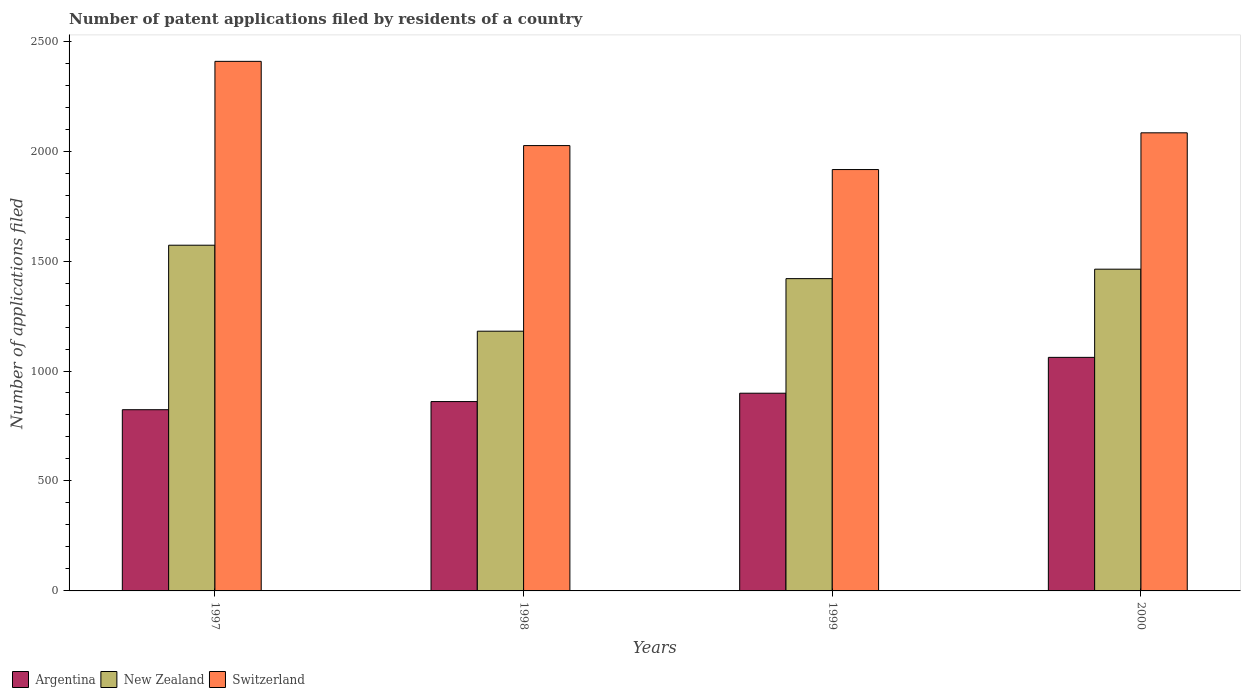How many groups of bars are there?
Your answer should be very brief. 4. How many bars are there on the 4th tick from the left?
Your answer should be very brief. 3. How many bars are there on the 2nd tick from the right?
Your answer should be compact. 3. What is the label of the 2nd group of bars from the left?
Make the answer very short. 1998. What is the number of applications filed in New Zealand in 1997?
Ensure brevity in your answer.  1572. Across all years, what is the maximum number of applications filed in Switzerland?
Provide a short and direct response. 2408. Across all years, what is the minimum number of applications filed in New Zealand?
Offer a very short reply. 1181. In which year was the number of applications filed in Argentina maximum?
Offer a terse response. 2000. In which year was the number of applications filed in Switzerland minimum?
Your answer should be compact. 1999. What is the total number of applications filed in Switzerland in the graph?
Offer a very short reply. 8432. What is the difference between the number of applications filed in Switzerland in 1997 and that in 1998?
Your answer should be very brief. 383. What is the difference between the number of applications filed in Switzerland in 1998 and the number of applications filed in New Zealand in 1999?
Ensure brevity in your answer.  605. What is the average number of applications filed in New Zealand per year?
Your answer should be compact. 1409. In the year 1998, what is the difference between the number of applications filed in Switzerland and number of applications filed in Argentina?
Your answer should be very brief. 1164. In how many years, is the number of applications filed in New Zealand greater than 1300?
Your response must be concise. 3. What is the ratio of the number of applications filed in New Zealand in 1997 to that in 2000?
Offer a terse response. 1.07. What is the difference between the highest and the second highest number of applications filed in New Zealand?
Provide a succinct answer. 109. What is the difference between the highest and the lowest number of applications filed in Argentina?
Your answer should be compact. 238. In how many years, is the number of applications filed in Argentina greater than the average number of applications filed in Argentina taken over all years?
Offer a very short reply. 1. What does the 2nd bar from the right in 2000 represents?
Your answer should be very brief. New Zealand. Is it the case that in every year, the sum of the number of applications filed in Argentina and number of applications filed in New Zealand is greater than the number of applications filed in Switzerland?
Give a very brief answer. No. Does the graph contain any zero values?
Ensure brevity in your answer.  No. Does the graph contain grids?
Your response must be concise. No. Where does the legend appear in the graph?
Your response must be concise. Bottom left. What is the title of the graph?
Provide a succinct answer. Number of patent applications filed by residents of a country. Does "Latin America(developing only)" appear as one of the legend labels in the graph?
Make the answer very short. No. What is the label or title of the X-axis?
Provide a short and direct response. Years. What is the label or title of the Y-axis?
Provide a succinct answer. Number of applications filed. What is the Number of applications filed in Argentina in 1997?
Keep it short and to the point. 824. What is the Number of applications filed in New Zealand in 1997?
Offer a terse response. 1572. What is the Number of applications filed in Switzerland in 1997?
Provide a short and direct response. 2408. What is the Number of applications filed in Argentina in 1998?
Make the answer very short. 861. What is the Number of applications filed in New Zealand in 1998?
Offer a very short reply. 1181. What is the Number of applications filed in Switzerland in 1998?
Your answer should be compact. 2025. What is the Number of applications filed in Argentina in 1999?
Your answer should be compact. 899. What is the Number of applications filed in New Zealand in 1999?
Give a very brief answer. 1420. What is the Number of applications filed in Switzerland in 1999?
Provide a succinct answer. 1916. What is the Number of applications filed of Argentina in 2000?
Keep it short and to the point. 1062. What is the Number of applications filed of New Zealand in 2000?
Make the answer very short. 1463. What is the Number of applications filed of Switzerland in 2000?
Offer a very short reply. 2083. Across all years, what is the maximum Number of applications filed of Argentina?
Offer a very short reply. 1062. Across all years, what is the maximum Number of applications filed of New Zealand?
Your response must be concise. 1572. Across all years, what is the maximum Number of applications filed of Switzerland?
Make the answer very short. 2408. Across all years, what is the minimum Number of applications filed of Argentina?
Your answer should be very brief. 824. Across all years, what is the minimum Number of applications filed in New Zealand?
Keep it short and to the point. 1181. Across all years, what is the minimum Number of applications filed in Switzerland?
Offer a terse response. 1916. What is the total Number of applications filed of Argentina in the graph?
Make the answer very short. 3646. What is the total Number of applications filed in New Zealand in the graph?
Your answer should be very brief. 5636. What is the total Number of applications filed of Switzerland in the graph?
Your answer should be very brief. 8432. What is the difference between the Number of applications filed of Argentina in 1997 and that in 1998?
Provide a succinct answer. -37. What is the difference between the Number of applications filed in New Zealand in 1997 and that in 1998?
Your response must be concise. 391. What is the difference between the Number of applications filed of Switzerland in 1997 and that in 1998?
Give a very brief answer. 383. What is the difference between the Number of applications filed of Argentina in 1997 and that in 1999?
Give a very brief answer. -75. What is the difference between the Number of applications filed in New Zealand in 1997 and that in 1999?
Give a very brief answer. 152. What is the difference between the Number of applications filed of Switzerland in 1997 and that in 1999?
Give a very brief answer. 492. What is the difference between the Number of applications filed of Argentina in 1997 and that in 2000?
Offer a terse response. -238. What is the difference between the Number of applications filed of New Zealand in 1997 and that in 2000?
Your response must be concise. 109. What is the difference between the Number of applications filed of Switzerland in 1997 and that in 2000?
Give a very brief answer. 325. What is the difference between the Number of applications filed of Argentina in 1998 and that in 1999?
Make the answer very short. -38. What is the difference between the Number of applications filed in New Zealand in 1998 and that in 1999?
Offer a terse response. -239. What is the difference between the Number of applications filed of Switzerland in 1998 and that in 1999?
Offer a terse response. 109. What is the difference between the Number of applications filed in Argentina in 1998 and that in 2000?
Your answer should be very brief. -201. What is the difference between the Number of applications filed of New Zealand in 1998 and that in 2000?
Offer a terse response. -282. What is the difference between the Number of applications filed in Switzerland in 1998 and that in 2000?
Provide a short and direct response. -58. What is the difference between the Number of applications filed in Argentina in 1999 and that in 2000?
Offer a terse response. -163. What is the difference between the Number of applications filed of New Zealand in 1999 and that in 2000?
Offer a very short reply. -43. What is the difference between the Number of applications filed of Switzerland in 1999 and that in 2000?
Your response must be concise. -167. What is the difference between the Number of applications filed in Argentina in 1997 and the Number of applications filed in New Zealand in 1998?
Provide a short and direct response. -357. What is the difference between the Number of applications filed in Argentina in 1997 and the Number of applications filed in Switzerland in 1998?
Provide a short and direct response. -1201. What is the difference between the Number of applications filed in New Zealand in 1997 and the Number of applications filed in Switzerland in 1998?
Offer a terse response. -453. What is the difference between the Number of applications filed of Argentina in 1997 and the Number of applications filed of New Zealand in 1999?
Provide a short and direct response. -596. What is the difference between the Number of applications filed in Argentina in 1997 and the Number of applications filed in Switzerland in 1999?
Provide a succinct answer. -1092. What is the difference between the Number of applications filed of New Zealand in 1997 and the Number of applications filed of Switzerland in 1999?
Provide a short and direct response. -344. What is the difference between the Number of applications filed of Argentina in 1997 and the Number of applications filed of New Zealand in 2000?
Your answer should be compact. -639. What is the difference between the Number of applications filed of Argentina in 1997 and the Number of applications filed of Switzerland in 2000?
Give a very brief answer. -1259. What is the difference between the Number of applications filed in New Zealand in 1997 and the Number of applications filed in Switzerland in 2000?
Ensure brevity in your answer.  -511. What is the difference between the Number of applications filed of Argentina in 1998 and the Number of applications filed of New Zealand in 1999?
Provide a succinct answer. -559. What is the difference between the Number of applications filed in Argentina in 1998 and the Number of applications filed in Switzerland in 1999?
Offer a very short reply. -1055. What is the difference between the Number of applications filed in New Zealand in 1998 and the Number of applications filed in Switzerland in 1999?
Your response must be concise. -735. What is the difference between the Number of applications filed of Argentina in 1998 and the Number of applications filed of New Zealand in 2000?
Give a very brief answer. -602. What is the difference between the Number of applications filed of Argentina in 1998 and the Number of applications filed of Switzerland in 2000?
Ensure brevity in your answer.  -1222. What is the difference between the Number of applications filed of New Zealand in 1998 and the Number of applications filed of Switzerland in 2000?
Provide a succinct answer. -902. What is the difference between the Number of applications filed of Argentina in 1999 and the Number of applications filed of New Zealand in 2000?
Make the answer very short. -564. What is the difference between the Number of applications filed of Argentina in 1999 and the Number of applications filed of Switzerland in 2000?
Make the answer very short. -1184. What is the difference between the Number of applications filed in New Zealand in 1999 and the Number of applications filed in Switzerland in 2000?
Provide a short and direct response. -663. What is the average Number of applications filed of Argentina per year?
Offer a terse response. 911.5. What is the average Number of applications filed of New Zealand per year?
Offer a very short reply. 1409. What is the average Number of applications filed of Switzerland per year?
Offer a very short reply. 2108. In the year 1997, what is the difference between the Number of applications filed in Argentina and Number of applications filed in New Zealand?
Your answer should be compact. -748. In the year 1997, what is the difference between the Number of applications filed in Argentina and Number of applications filed in Switzerland?
Your response must be concise. -1584. In the year 1997, what is the difference between the Number of applications filed in New Zealand and Number of applications filed in Switzerland?
Give a very brief answer. -836. In the year 1998, what is the difference between the Number of applications filed in Argentina and Number of applications filed in New Zealand?
Offer a terse response. -320. In the year 1998, what is the difference between the Number of applications filed of Argentina and Number of applications filed of Switzerland?
Provide a short and direct response. -1164. In the year 1998, what is the difference between the Number of applications filed in New Zealand and Number of applications filed in Switzerland?
Your response must be concise. -844. In the year 1999, what is the difference between the Number of applications filed in Argentina and Number of applications filed in New Zealand?
Offer a terse response. -521. In the year 1999, what is the difference between the Number of applications filed in Argentina and Number of applications filed in Switzerland?
Ensure brevity in your answer.  -1017. In the year 1999, what is the difference between the Number of applications filed of New Zealand and Number of applications filed of Switzerland?
Your response must be concise. -496. In the year 2000, what is the difference between the Number of applications filed in Argentina and Number of applications filed in New Zealand?
Keep it short and to the point. -401. In the year 2000, what is the difference between the Number of applications filed in Argentina and Number of applications filed in Switzerland?
Keep it short and to the point. -1021. In the year 2000, what is the difference between the Number of applications filed in New Zealand and Number of applications filed in Switzerland?
Keep it short and to the point. -620. What is the ratio of the Number of applications filed of New Zealand in 1997 to that in 1998?
Ensure brevity in your answer.  1.33. What is the ratio of the Number of applications filed of Switzerland in 1997 to that in 1998?
Your response must be concise. 1.19. What is the ratio of the Number of applications filed in Argentina in 1997 to that in 1999?
Provide a short and direct response. 0.92. What is the ratio of the Number of applications filed of New Zealand in 1997 to that in 1999?
Make the answer very short. 1.11. What is the ratio of the Number of applications filed in Switzerland in 1997 to that in 1999?
Give a very brief answer. 1.26. What is the ratio of the Number of applications filed of Argentina in 1997 to that in 2000?
Give a very brief answer. 0.78. What is the ratio of the Number of applications filed of New Zealand in 1997 to that in 2000?
Make the answer very short. 1.07. What is the ratio of the Number of applications filed of Switzerland in 1997 to that in 2000?
Make the answer very short. 1.16. What is the ratio of the Number of applications filed in Argentina in 1998 to that in 1999?
Provide a succinct answer. 0.96. What is the ratio of the Number of applications filed of New Zealand in 1998 to that in 1999?
Provide a short and direct response. 0.83. What is the ratio of the Number of applications filed of Switzerland in 1998 to that in 1999?
Ensure brevity in your answer.  1.06. What is the ratio of the Number of applications filed of Argentina in 1998 to that in 2000?
Keep it short and to the point. 0.81. What is the ratio of the Number of applications filed of New Zealand in 1998 to that in 2000?
Provide a succinct answer. 0.81. What is the ratio of the Number of applications filed in Switzerland in 1998 to that in 2000?
Keep it short and to the point. 0.97. What is the ratio of the Number of applications filed in Argentina in 1999 to that in 2000?
Offer a terse response. 0.85. What is the ratio of the Number of applications filed of New Zealand in 1999 to that in 2000?
Your response must be concise. 0.97. What is the ratio of the Number of applications filed of Switzerland in 1999 to that in 2000?
Your answer should be compact. 0.92. What is the difference between the highest and the second highest Number of applications filed in Argentina?
Your answer should be compact. 163. What is the difference between the highest and the second highest Number of applications filed in New Zealand?
Offer a terse response. 109. What is the difference between the highest and the second highest Number of applications filed in Switzerland?
Keep it short and to the point. 325. What is the difference between the highest and the lowest Number of applications filed of Argentina?
Give a very brief answer. 238. What is the difference between the highest and the lowest Number of applications filed in New Zealand?
Offer a terse response. 391. What is the difference between the highest and the lowest Number of applications filed in Switzerland?
Offer a terse response. 492. 